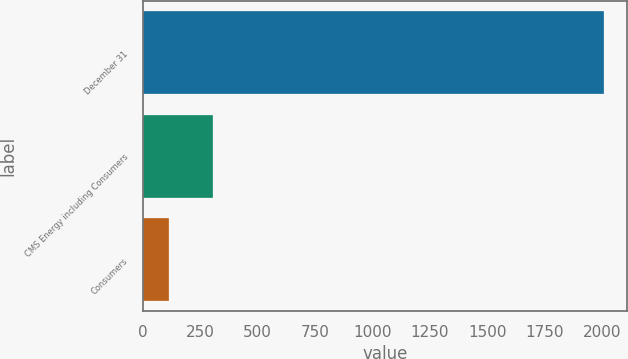<chart> <loc_0><loc_0><loc_500><loc_500><bar_chart><fcel>December 31<fcel>CMS Energy including Consumers<fcel>Consumers<nl><fcel>2010<fcel>302.7<fcel>113<nl></chart> 